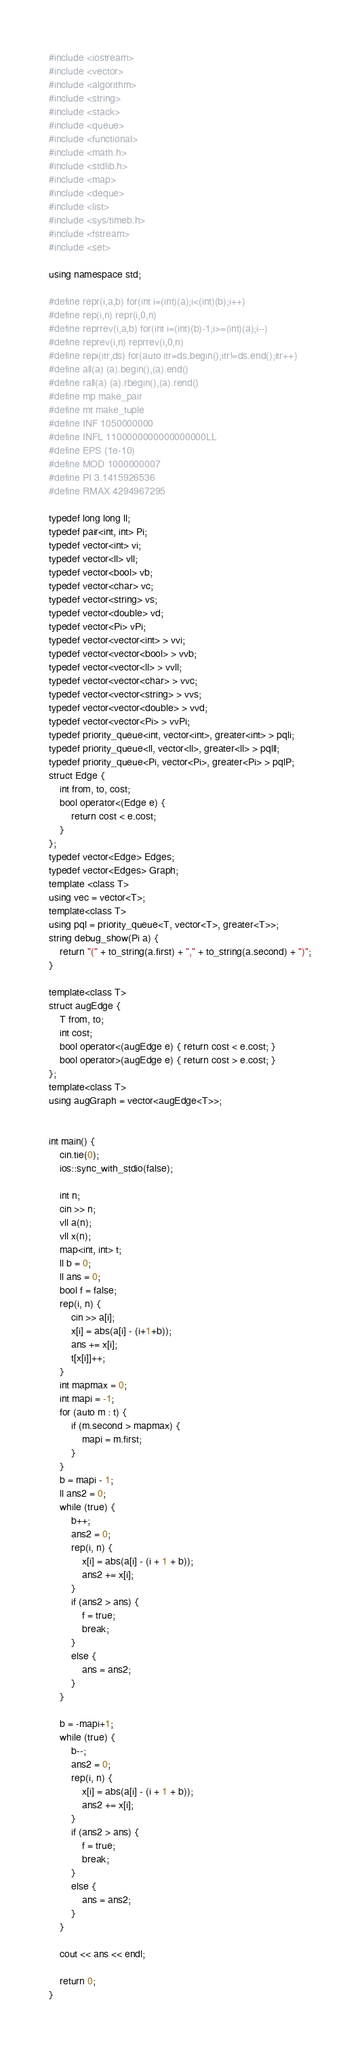Convert code to text. <code><loc_0><loc_0><loc_500><loc_500><_C++_>
#include <iostream>
#include <vector>
#include <algorithm>
#include <string>
#include <stack>
#include <queue>
#include <functional>
#include <math.h>
#include <stdlib.h>
#include <map>
#include <deque>
#include <list>
#include <sys/timeb.h>
#include <fstream>
#include <set>

using namespace std;

#define repr(i,a,b) for(int i=(int)(a);i<(int)(b);i++)
#define rep(i,n) repr(i,0,n)
#define reprrev(i,a,b) for(int i=(int)(b)-1;i>=(int)(a);i--)
#define reprev(i,n) reprrev(i,0,n)
#define repi(itr,ds) for(auto itr=ds.begin();itr!=ds.end();itr++)
#define all(a) (a).begin(),(a).end()
#define rall(a) (a).rbegin(),(a).rend()
#define mp make_pair
#define mt make_tuple
#define INF 1050000000
#define INFL 1100000000000000000LL
#define EPS (1e-10)
#define MOD 1000000007
#define PI 3.1415926536
#define RMAX 4294967295

typedef long long ll;
typedef pair<int, int> Pi;
typedef vector<int> vi;
typedef vector<ll> vll;
typedef vector<bool> vb;
typedef vector<char> vc;
typedef vector<string> vs;
typedef vector<double> vd;
typedef vector<Pi> vPi;
typedef vector<vector<int> > vvi;
typedef vector<vector<bool> > vvb;
typedef vector<vector<ll> > vvll;
typedef vector<vector<char> > vvc;
typedef vector<vector<string> > vvs;
typedef vector<vector<double> > vvd;
typedef vector<vector<Pi> > vvPi;
typedef priority_queue<int, vector<int>, greater<int> > pqli;
typedef priority_queue<ll, vector<ll>, greater<ll> > pqlll;
typedef priority_queue<Pi, vector<Pi>, greater<Pi> > pqlP;
struct Edge {
	int from, to, cost;
	bool operator<(Edge e) {
		return cost < e.cost;
	}
};
typedef vector<Edge> Edges;
typedef vector<Edges> Graph;
template <class T>
using vec = vector<T>;
template<class T>
using pql = priority_queue<T, vector<T>, greater<T>>;
string debug_show(Pi a) {
	return "(" + to_string(a.first) + "," + to_string(a.second) + ")";
}

template<class T>
struct augEdge {
	T from, to;
	int cost;
	bool operator<(augEdge e) { return cost < e.cost; }
	bool operator>(augEdge e) { return cost > e.cost; }
};
template<class T>
using augGraph = vector<augEdge<T>>;


int main() {
	cin.tie(0);
	ios::sync_with_stdio(false);

	int n;
	cin >> n;
	vll a(n);
	vll x(n);
	map<int, int> t;
	ll b = 0;
	ll ans = 0;
	bool f = false;
	rep(i, n) {
		cin >> a[i];
		x[i] = abs(a[i] - (i+1+b));
		ans += x[i];
		t[x[i]]++;
	}
	int mapmax = 0;
	int mapi = -1;
	for (auto m : t) {
		if (m.second > mapmax) {
			mapi = m.first;
		}
	}
	b = mapi - 1;
	ll ans2 = 0;
	while (true) {
		b++;
		ans2 = 0;
		rep(i, n) {
			x[i] = abs(a[i] - (i + 1 + b));
			ans2 += x[i];
		}
		if (ans2 > ans) {
			f = true;
			break;
		}
		else {
			ans = ans2;
		}
	}

	b = -mapi+1;
	while (true) {
		b--;
		ans2 = 0;
		rep(i, n) {
			x[i] = abs(a[i] - (i + 1 + b));
			ans2 += x[i];
		}
		if (ans2 > ans) {
			f = true;
			break;
		}
		else {
			ans = ans2;
		}
	}

	cout << ans << endl;

	return 0;
}

</code> 